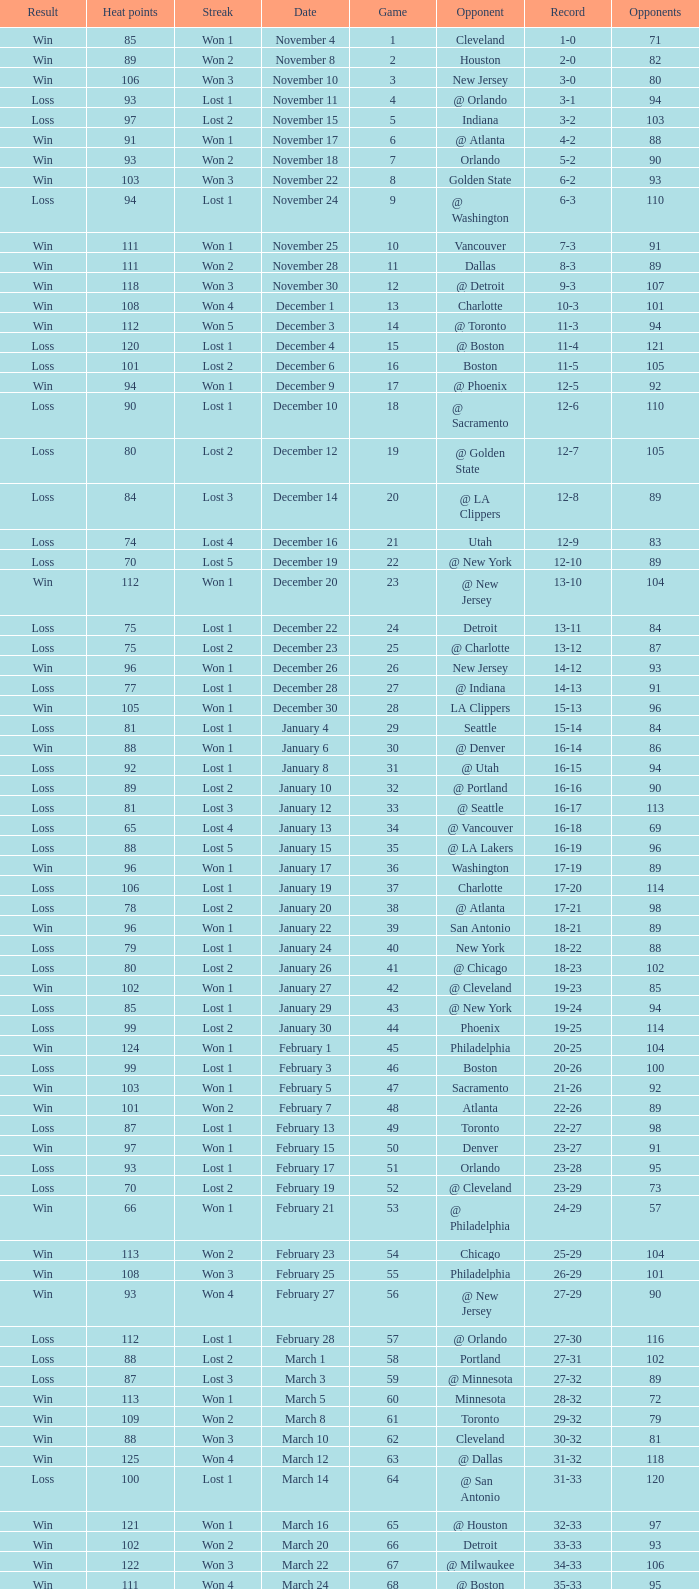What is Heat Points, when Game is less than 80, and when Date is "April 26 (First Round)"? 85.0. 